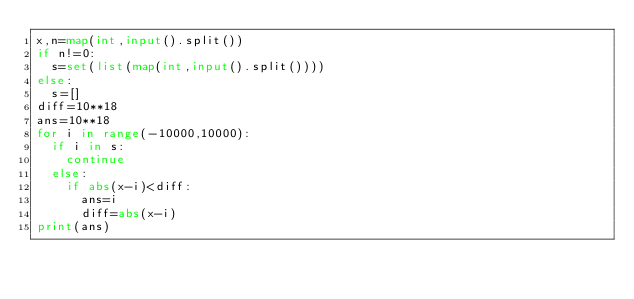<code> <loc_0><loc_0><loc_500><loc_500><_Python_>x,n=map(int,input().split())
if n!=0:
  s=set(list(map(int,input().split())))
else:
  s=[]
diff=10**18
ans=10**18
for i in range(-10000,10000):
  if i in s:
    continue
  else:
    if abs(x-i)<diff:
      ans=i
      diff=abs(x-i)
print(ans)</code> 